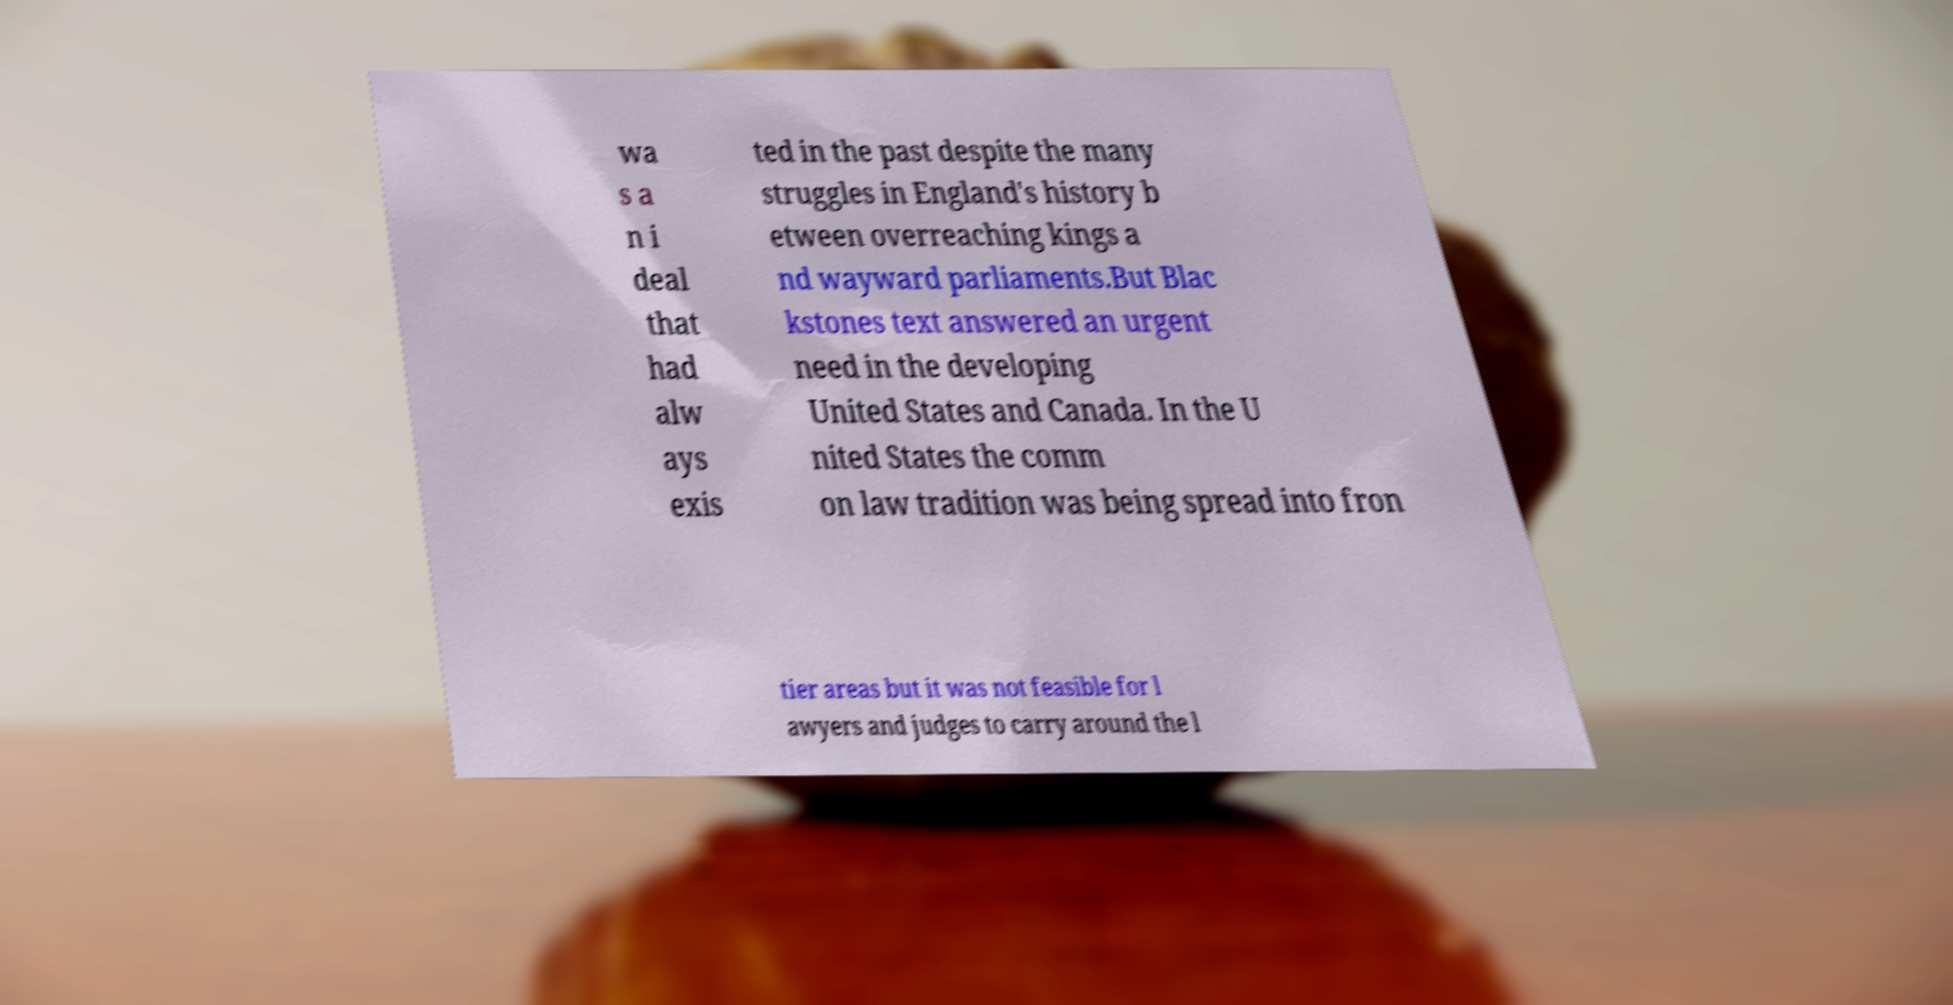There's text embedded in this image that I need extracted. Can you transcribe it verbatim? wa s a n i deal that had alw ays exis ted in the past despite the many struggles in England's history b etween overreaching kings a nd wayward parliaments.But Blac kstones text answered an urgent need in the developing United States and Canada. In the U nited States the comm on law tradition was being spread into fron tier areas but it was not feasible for l awyers and judges to carry around the l 